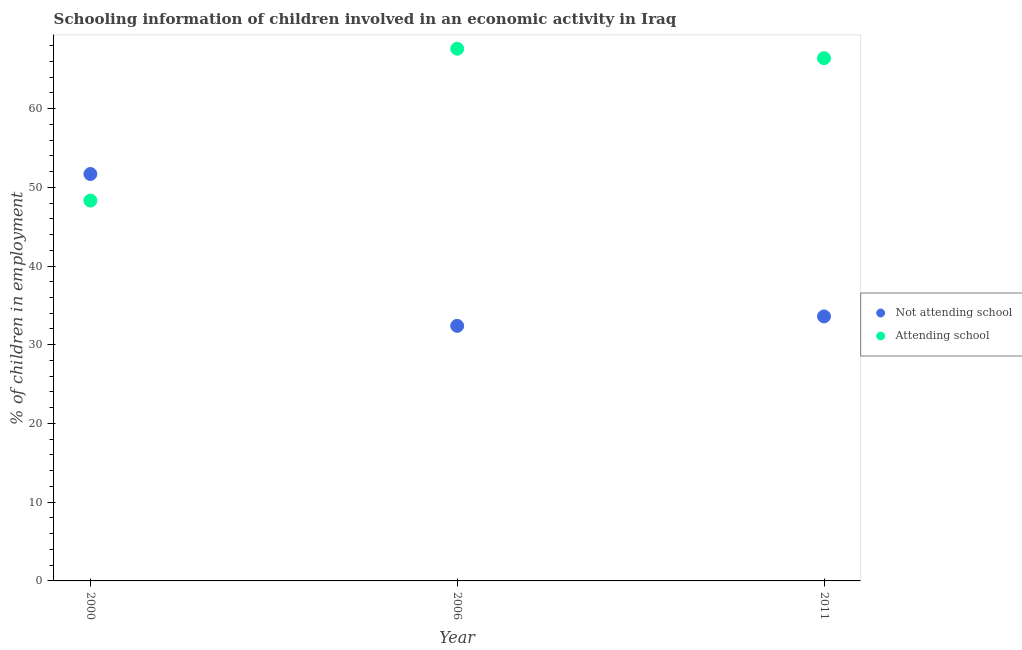How many different coloured dotlines are there?
Keep it short and to the point. 2. What is the percentage of employed children who are not attending school in 2000?
Keep it short and to the point. 51.69. Across all years, what is the maximum percentage of employed children who are not attending school?
Offer a terse response. 51.69. Across all years, what is the minimum percentage of employed children who are not attending school?
Offer a terse response. 32.4. In which year was the percentage of employed children who are attending school maximum?
Offer a terse response. 2006. What is the total percentage of employed children who are not attending school in the graph?
Keep it short and to the point. 117.69. What is the difference between the percentage of employed children who are attending school in 2000 and that in 2011?
Your answer should be compact. -18.09. What is the difference between the percentage of employed children who are not attending school in 2011 and the percentage of employed children who are attending school in 2000?
Make the answer very short. -14.71. What is the average percentage of employed children who are not attending school per year?
Your answer should be very brief. 39.23. In the year 2011, what is the difference between the percentage of employed children who are not attending school and percentage of employed children who are attending school?
Ensure brevity in your answer.  -32.8. In how many years, is the percentage of employed children who are attending school greater than 28 %?
Keep it short and to the point. 3. What is the ratio of the percentage of employed children who are attending school in 2006 to that in 2011?
Keep it short and to the point. 1.02. What is the difference between the highest and the second highest percentage of employed children who are attending school?
Your answer should be very brief. 1.2. What is the difference between the highest and the lowest percentage of employed children who are not attending school?
Your answer should be compact. 19.29. In how many years, is the percentage of employed children who are attending school greater than the average percentage of employed children who are attending school taken over all years?
Ensure brevity in your answer.  2. Does the percentage of employed children who are attending school monotonically increase over the years?
Keep it short and to the point. No. Is the percentage of employed children who are not attending school strictly less than the percentage of employed children who are attending school over the years?
Your answer should be very brief. No. How many dotlines are there?
Provide a succinct answer. 2. How many years are there in the graph?
Offer a terse response. 3. What is the difference between two consecutive major ticks on the Y-axis?
Make the answer very short. 10. Are the values on the major ticks of Y-axis written in scientific E-notation?
Provide a short and direct response. No. Does the graph contain grids?
Provide a short and direct response. No. Where does the legend appear in the graph?
Provide a short and direct response. Center right. What is the title of the graph?
Make the answer very short. Schooling information of children involved in an economic activity in Iraq. What is the label or title of the Y-axis?
Offer a terse response. % of children in employment. What is the % of children in employment of Not attending school in 2000?
Your answer should be very brief. 51.69. What is the % of children in employment in Attending school in 2000?
Make the answer very short. 48.31. What is the % of children in employment of Not attending school in 2006?
Your answer should be very brief. 32.4. What is the % of children in employment in Attending school in 2006?
Offer a very short reply. 67.6. What is the % of children in employment of Not attending school in 2011?
Your answer should be very brief. 33.6. What is the % of children in employment of Attending school in 2011?
Provide a short and direct response. 66.4. Across all years, what is the maximum % of children in employment in Not attending school?
Offer a terse response. 51.69. Across all years, what is the maximum % of children in employment of Attending school?
Your answer should be compact. 67.6. Across all years, what is the minimum % of children in employment in Not attending school?
Provide a short and direct response. 32.4. Across all years, what is the minimum % of children in employment of Attending school?
Provide a succinct answer. 48.31. What is the total % of children in employment of Not attending school in the graph?
Your answer should be compact. 117.69. What is the total % of children in employment in Attending school in the graph?
Provide a succinct answer. 182.31. What is the difference between the % of children in employment of Not attending school in 2000 and that in 2006?
Offer a very short reply. 19.29. What is the difference between the % of children in employment in Attending school in 2000 and that in 2006?
Ensure brevity in your answer.  -19.29. What is the difference between the % of children in employment of Not attending school in 2000 and that in 2011?
Your response must be concise. 18.09. What is the difference between the % of children in employment in Attending school in 2000 and that in 2011?
Your response must be concise. -18.09. What is the difference between the % of children in employment of Not attending school in 2006 and that in 2011?
Ensure brevity in your answer.  -1.2. What is the difference between the % of children in employment in Not attending school in 2000 and the % of children in employment in Attending school in 2006?
Offer a very short reply. -15.91. What is the difference between the % of children in employment of Not attending school in 2000 and the % of children in employment of Attending school in 2011?
Provide a succinct answer. -14.71. What is the difference between the % of children in employment of Not attending school in 2006 and the % of children in employment of Attending school in 2011?
Your answer should be very brief. -34. What is the average % of children in employment of Not attending school per year?
Give a very brief answer. 39.23. What is the average % of children in employment in Attending school per year?
Your answer should be compact. 60.77. In the year 2000, what is the difference between the % of children in employment of Not attending school and % of children in employment of Attending school?
Provide a short and direct response. 3.37. In the year 2006, what is the difference between the % of children in employment in Not attending school and % of children in employment in Attending school?
Your answer should be compact. -35.2. In the year 2011, what is the difference between the % of children in employment of Not attending school and % of children in employment of Attending school?
Make the answer very short. -32.8. What is the ratio of the % of children in employment in Not attending school in 2000 to that in 2006?
Provide a short and direct response. 1.6. What is the ratio of the % of children in employment in Attending school in 2000 to that in 2006?
Provide a succinct answer. 0.71. What is the ratio of the % of children in employment of Not attending school in 2000 to that in 2011?
Your response must be concise. 1.54. What is the ratio of the % of children in employment in Attending school in 2000 to that in 2011?
Give a very brief answer. 0.73. What is the ratio of the % of children in employment of Not attending school in 2006 to that in 2011?
Provide a short and direct response. 0.96. What is the ratio of the % of children in employment in Attending school in 2006 to that in 2011?
Give a very brief answer. 1.02. What is the difference between the highest and the second highest % of children in employment in Not attending school?
Keep it short and to the point. 18.09. What is the difference between the highest and the lowest % of children in employment of Not attending school?
Make the answer very short. 19.29. What is the difference between the highest and the lowest % of children in employment in Attending school?
Keep it short and to the point. 19.29. 